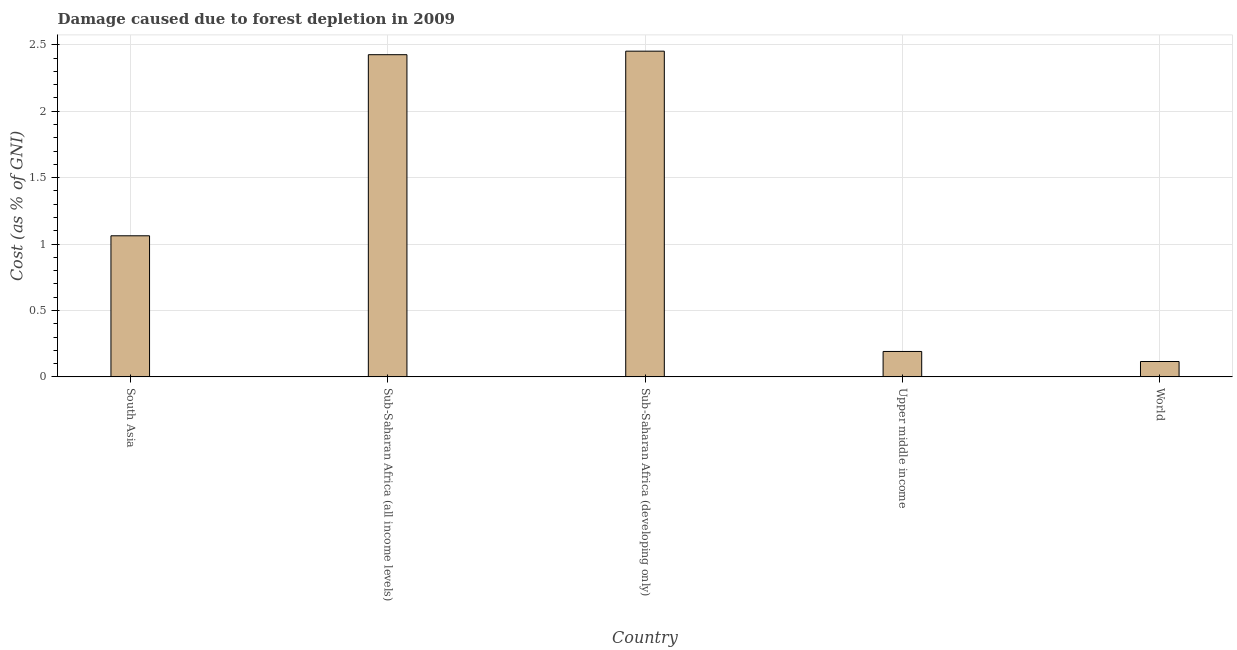Does the graph contain grids?
Ensure brevity in your answer.  Yes. What is the title of the graph?
Your response must be concise. Damage caused due to forest depletion in 2009. What is the label or title of the X-axis?
Your response must be concise. Country. What is the label or title of the Y-axis?
Provide a succinct answer. Cost (as % of GNI). What is the damage caused due to forest depletion in Sub-Saharan Africa (all income levels)?
Your response must be concise. 2.43. Across all countries, what is the maximum damage caused due to forest depletion?
Provide a succinct answer. 2.45. Across all countries, what is the minimum damage caused due to forest depletion?
Offer a very short reply. 0.12. In which country was the damage caused due to forest depletion maximum?
Give a very brief answer. Sub-Saharan Africa (developing only). In which country was the damage caused due to forest depletion minimum?
Provide a short and direct response. World. What is the sum of the damage caused due to forest depletion?
Your answer should be compact. 6.25. What is the difference between the damage caused due to forest depletion in South Asia and Sub-Saharan Africa (all income levels)?
Your answer should be very brief. -1.36. What is the average damage caused due to forest depletion per country?
Give a very brief answer. 1.25. What is the median damage caused due to forest depletion?
Offer a terse response. 1.06. In how many countries, is the damage caused due to forest depletion greater than 1.6 %?
Provide a succinct answer. 2. What is the ratio of the damage caused due to forest depletion in South Asia to that in Sub-Saharan Africa (developing only)?
Give a very brief answer. 0.43. Is the difference between the damage caused due to forest depletion in South Asia and Upper middle income greater than the difference between any two countries?
Your answer should be compact. No. What is the difference between the highest and the second highest damage caused due to forest depletion?
Provide a short and direct response. 0.03. Is the sum of the damage caused due to forest depletion in Sub-Saharan Africa (all income levels) and World greater than the maximum damage caused due to forest depletion across all countries?
Your response must be concise. Yes. What is the difference between the highest and the lowest damage caused due to forest depletion?
Make the answer very short. 2.34. In how many countries, is the damage caused due to forest depletion greater than the average damage caused due to forest depletion taken over all countries?
Keep it short and to the point. 2. Are all the bars in the graph horizontal?
Your response must be concise. No. Are the values on the major ticks of Y-axis written in scientific E-notation?
Provide a short and direct response. No. What is the Cost (as % of GNI) of South Asia?
Your answer should be very brief. 1.06. What is the Cost (as % of GNI) in Sub-Saharan Africa (all income levels)?
Keep it short and to the point. 2.43. What is the Cost (as % of GNI) of Sub-Saharan Africa (developing only)?
Offer a terse response. 2.45. What is the Cost (as % of GNI) in Upper middle income?
Offer a very short reply. 0.19. What is the Cost (as % of GNI) in World?
Offer a very short reply. 0.12. What is the difference between the Cost (as % of GNI) in South Asia and Sub-Saharan Africa (all income levels)?
Offer a very short reply. -1.36. What is the difference between the Cost (as % of GNI) in South Asia and Sub-Saharan Africa (developing only)?
Your answer should be very brief. -1.39. What is the difference between the Cost (as % of GNI) in South Asia and Upper middle income?
Ensure brevity in your answer.  0.87. What is the difference between the Cost (as % of GNI) in South Asia and World?
Offer a very short reply. 0.95. What is the difference between the Cost (as % of GNI) in Sub-Saharan Africa (all income levels) and Sub-Saharan Africa (developing only)?
Keep it short and to the point. -0.03. What is the difference between the Cost (as % of GNI) in Sub-Saharan Africa (all income levels) and Upper middle income?
Offer a very short reply. 2.23. What is the difference between the Cost (as % of GNI) in Sub-Saharan Africa (all income levels) and World?
Give a very brief answer. 2.31. What is the difference between the Cost (as % of GNI) in Sub-Saharan Africa (developing only) and Upper middle income?
Provide a succinct answer. 2.26. What is the difference between the Cost (as % of GNI) in Sub-Saharan Africa (developing only) and World?
Your response must be concise. 2.34. What is the difference between the Cost (as % of GNI) in Upper middle income and World?
Give a very brief answer. 0.08. What is the ratio of the Cost (as % of GNI) in South Asia to that in Sub-Saharan Africa (all income levels)?
Your response must be concise. 0.44. What is the ratio of the Cost (as % of GNI) in South Asia to that in Sub-Saharan Africa (developing only)?
Make the answer very short. 0.43. What is the ratio of the Cost (as % of GNI) in South Asia to that in Upper middle income?
Provide a short and direct response. 5.55. What is the ratio of the Cost (as % of GNI) in South Asia to that in World?
Give a very brief answer. 9.19. What is the ratio of the Cost (as % of GNI) in Sub-Saharan Africa (all income levels) to that in Upper middle income?
Offer a very short reply. 12.68. What is the ratio of the Cost (as % of GNI) in Sub-Saharan Africa (all income levels) to that in World?
Your answer should be very brief. 20.98. What is the ratio of the Cost (as % of GNI) in Sub-Saharan Africa (developing only) to that in Upper middle income?
Provide a short and direct response. 12.82. What is the ratio of the Cost (as % of GNI) in Sub-Saharan Africa (developing only) to that in World?
Your answer should be very brief. 21.21. What is the ratio of the Cost (as % of GNI) in Upper middle income to that in World?
Ensure brevity in your answer.  1.66. 